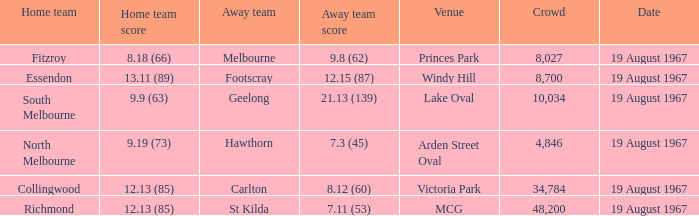When the away team scored 7.11 (53) what venue did they play at? MCG. 